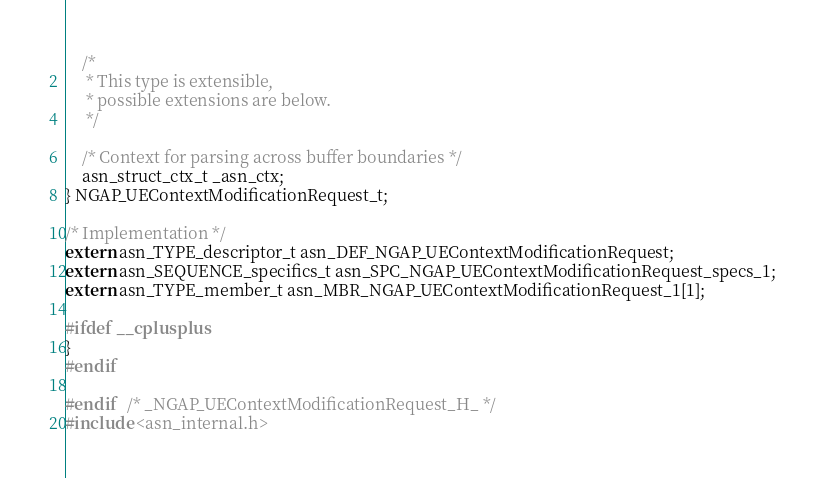<code> <loc_0><loc_0><loc_500><loc_500><_C_>	/*
	 * This type is extensible,
	 * possible extensions are below.
	 */
	
	/* Context for parsing across buffer boundaries */
	asn_struct_ctx_t _asn_ctx;
} NGAP_UEContextModificationRequest_t;

/* Implementation */
extern asn_TYPE_descriptor_t asn_DEF_NGAP_UEContextModificationRequest;
extern asn_SEQUENCE_specifics_t asn_SPC_NGAP_UEContextModificationRequest_specs_1;
extern asn_TYPE_member_t asn_MBR_NGAP_UEContextModificationRequest_1[1];

#ifdef __cplusplus
}
#endif

#endif	/* _NGAP_UEContextModificationRequest_H_ */
#include <asn_internal.h>
</code> 